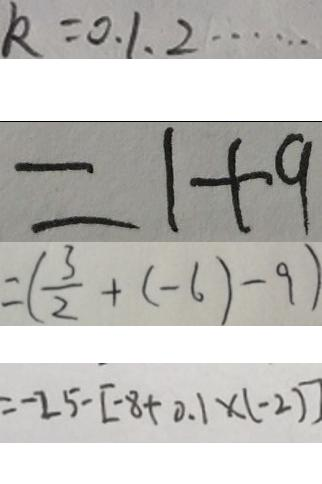<formula> <loc_0><loc_0><loc_500><loc_500>k = 0 , 1 , 2 \cdots 
 = 1 + 9 
 = ( \frac { 3 } { 2 } + ( - 6 ) - 9 ) 
 = - 2 5 - [ - 8 + 0 . 1 \times ( - 2 ) ]</formula> 